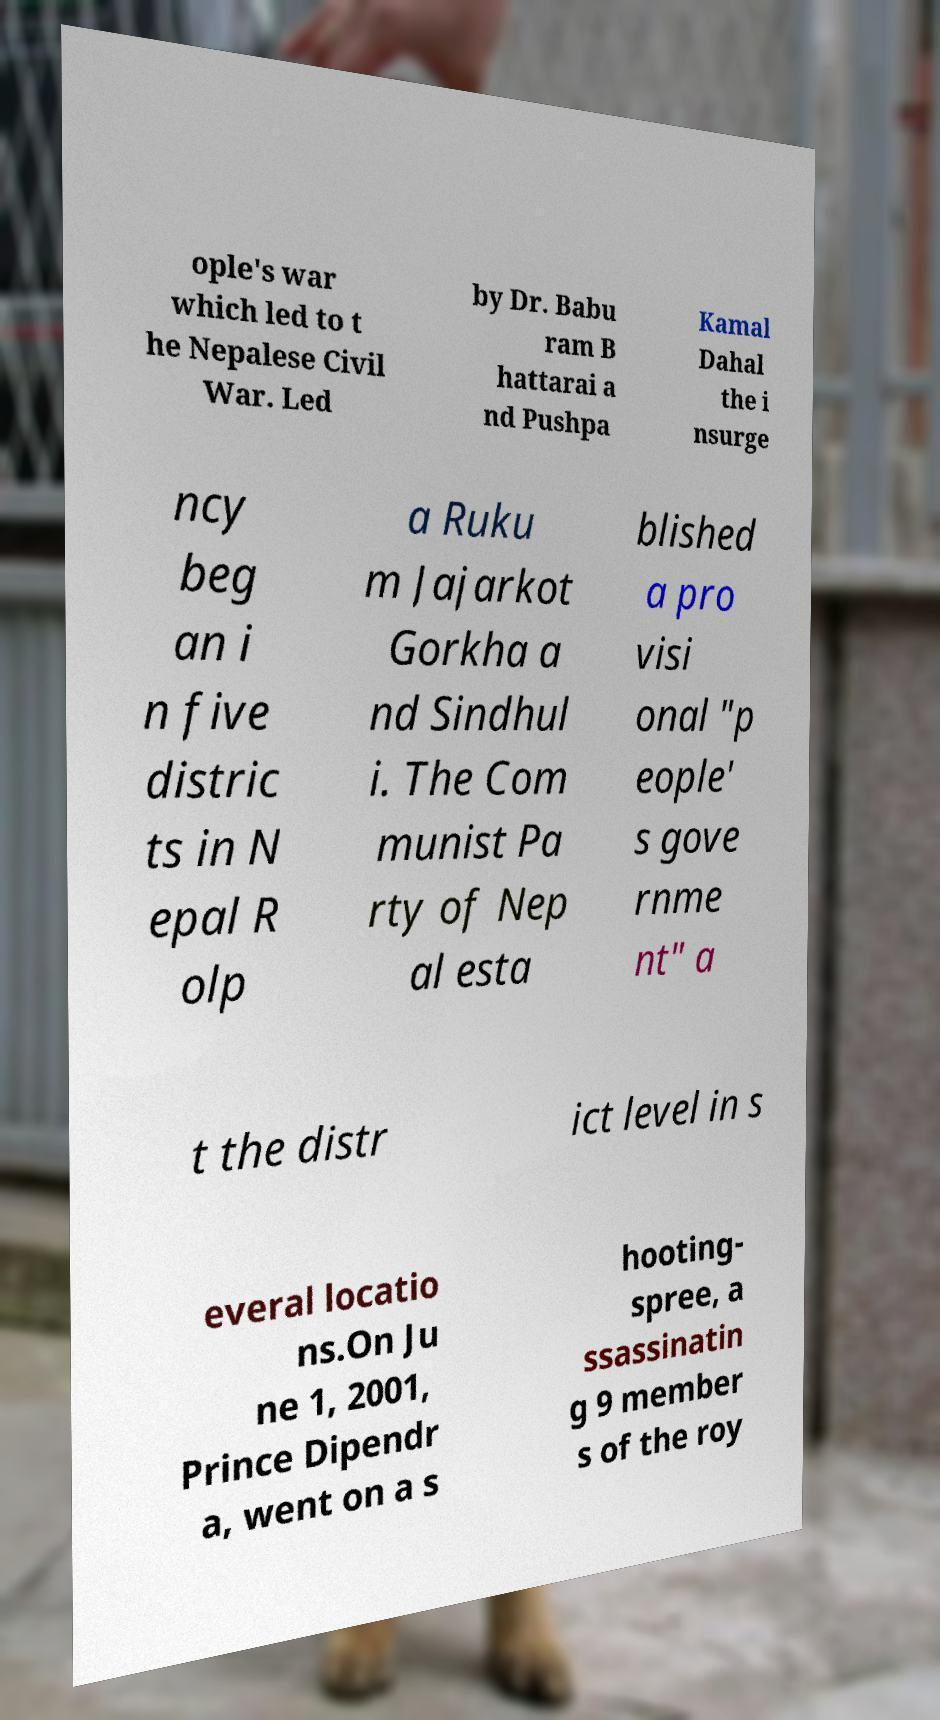Please identify and transcribe the text found in this image. ople's war which led to t he Nepalese Civil War. Led by Dr. Babu ram B hattarai a nd Pushpa Kamal Dahal the i nsurge ncy beg an i n five distric ts in N epal R olp a Ruku m Jajarkot Gorkha a nd Sindhul i. The Com munist Pa rty of Nep al esta blished a pro visi onal "p eople' s gove rnme nt" a t the distr ict level in s everal locatio ns.On Ju ne 1, 2001, Prince Dipendr a, went on a s hooting- spree, a ssassinatin g 9 member s of the roy 